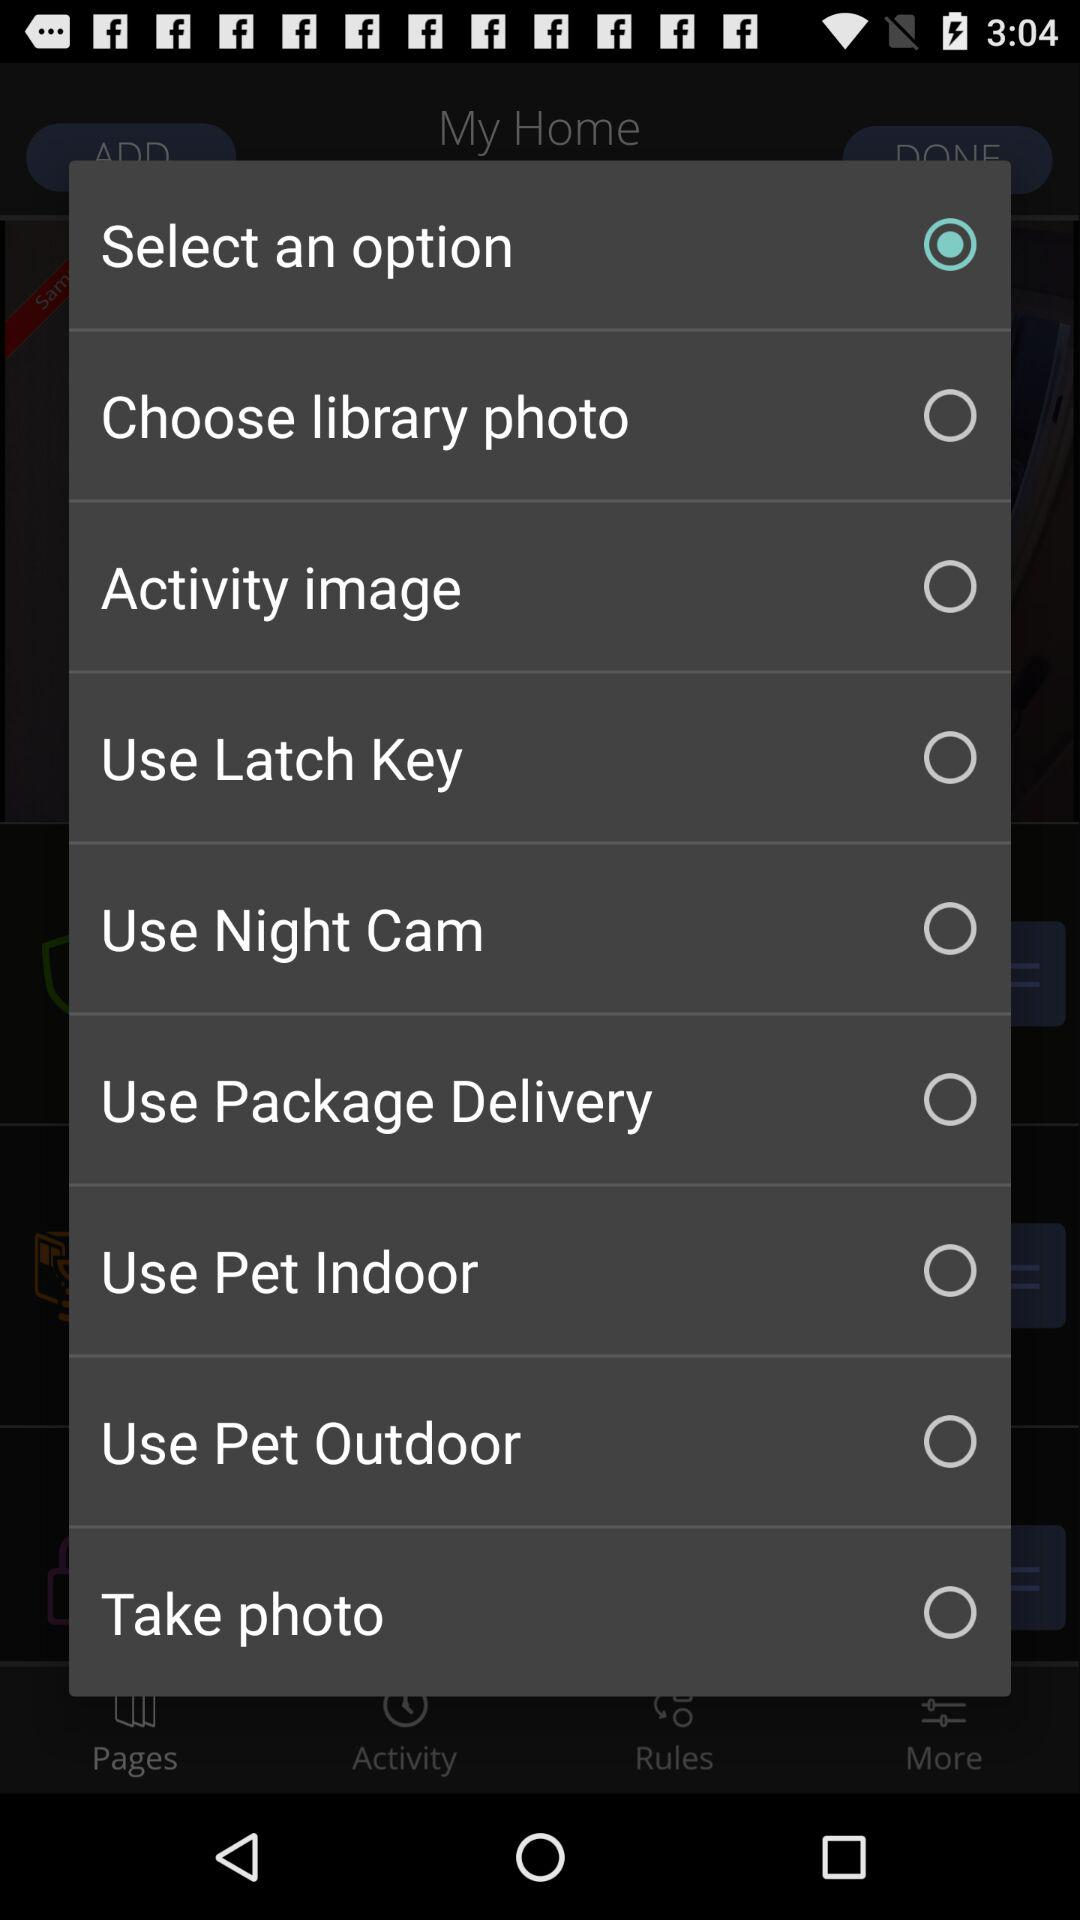Which option was selected? The selected options were "Select an option" and "Pages". 